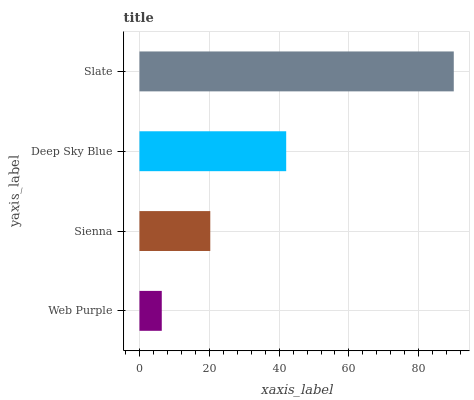Is Web Purple the minimum?
Answer yes or no. Yes. Is Slate the maximum?
Answer yes or no. Yes. Is Sienna the minimum?
Answer yes or no. No. Is Sienna the maximum?
Answer yes or no. No. Is Sienna greater than Web Purple?
Answer yes or no. Yes. Is Web Purple less than Sienna?
Answer yes or no. Yes. Is Web Purple greater than Sienna?
Answer yes or no. No. Is Sienna less than Web Purple?
Answer yes or no. No. Is Deep Sky Blue the high median?
Answer yes or no. Yes. Is Sienna the low median?
Answer yes or no. Yes. Is Slate the high median?
Answer yes or no. No. Is Web Purple the low median?
Answer yes or no. No. 